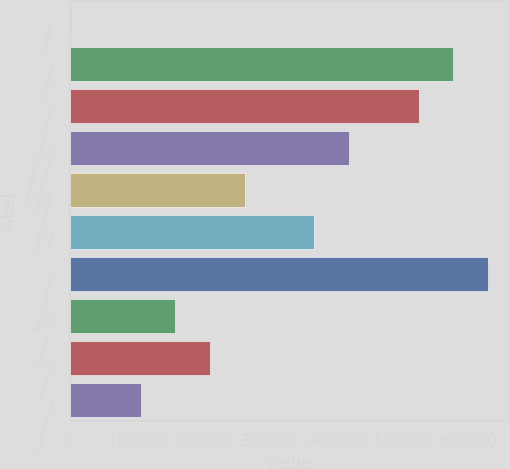Convert chart to OTSL. <chart><loc_0><loc_0><loc_500><loc_500><bar_chart><fcel>in millions<fcel>Derivatives<fcel>Commitments guarantees and<fcel>Securities financing<fcel>Equity investments<fcel>Other<fcel>Total Credit RWAs<fcel>Regulatory VaR<fcel>Stressed VaR<fcel>Incremental risk<nl><fcel>2015<fcel>576316<fcel>524107<fcel>419689<fcel>263061<fcel>367479<fcel>628525<fcel>158643<fcel>210852<fcel>106433<nl></chart> 